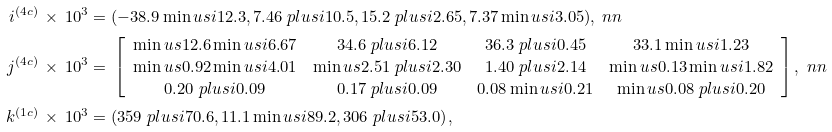<formula> <loc_0><loc_0><loc_500><loc_500>i ^ { ( 4 c ) } \, \times \, 1 0 ^ { 3 } & = ( - 3 8 . 9 \min u s i 1 2 . 3 , 7 . 4 6 \ p l u s i 1 0 . 5 , 1 5 . 2 \ p l u s i 2 . 6 5 , 7 . 3 7 \min u s i 3 . 0 5 ) , \ n n \\ j ^ { ( 4 c ) } \, \times \, 1 0 ^ { 3 } & = \, \left [ { \begin{array} { c c c c } \min u s 1 2 . 6 \min u s i 6 . 6 7 & 3 4 . 6 \ p l u s i 6 . 1 2 & 3 6 . 3 \ p l u s i 0 . 4 5 & 3 3 . 1 \min u s i 1 . 2 3 \\ \min u s 0 . 9 2 \min u s i 4 . 0 1 & \min u s 2 . 5 1 \ p l u s i 2 . 3 0 & 1 . 4 0 \ p l u s i 2 . 1 4 & \min u s 0 . 1 3 \min u s i 1 . 8 2 \\ 0 . 2 0 \ p l u s i 0 . 0 9 & 0 . 1 7 \ p l u s i 0 . 0 9 & 0 . 0 8 \min u s i 0 . 2 1 & \min u s 0 . 0 8 \ p l u s i 0 . 2 0 \end{array} } \right ] , \ n n \\ k ^ { ( 1 c ) } \, \times \, 1 0 ^ { 3 } & = ( 3 5 9 \ p l u s i 7 0 . 6 , 1 1 . 1 \min u s i 8 9 . 2 , 3 0 6 \ p l u s i 5 3 . 0 ) \, ,</formula> 